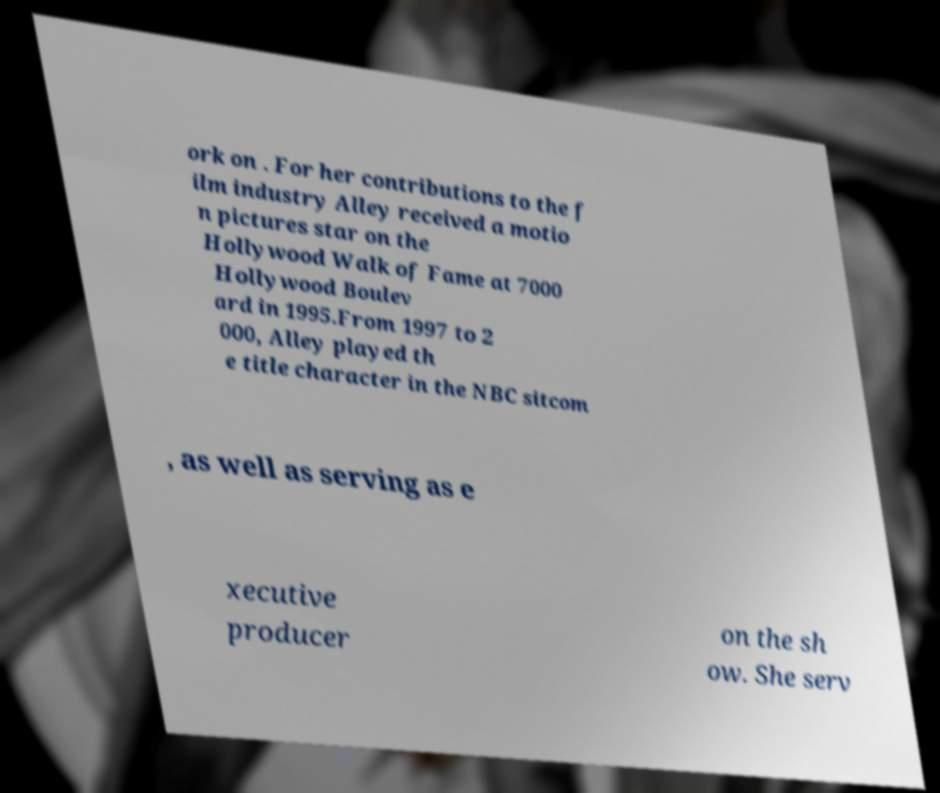Could you assist in decoding the text presented in this image and type it out clearly? ork on . For her contributions to the f ilm industry Alley received a motio n pictures star on the Hollywood Walk of Fame at 7000 Hollywood Boulev ard in 1995.From 1997 to 2 000, Alley played th e title character in the NBC sitcom , as well as serving as e xecutive producer on the sh ow. She serv 